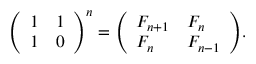<formula> <loc_0><loc_0><loc_500><loc_500>{ \left ( \begin{array} { l l } { 1 } & { 1 } \\ { 1 } & { 0 } \end{array} \right ) } ^ { n } = { \left ( \begin{array} { l l } { F _ { n + 1 } } & { F _ { n } } \\ { F _ { n } } & { F _ { n - 1 } } \end{array} \right ) } .</formula> 